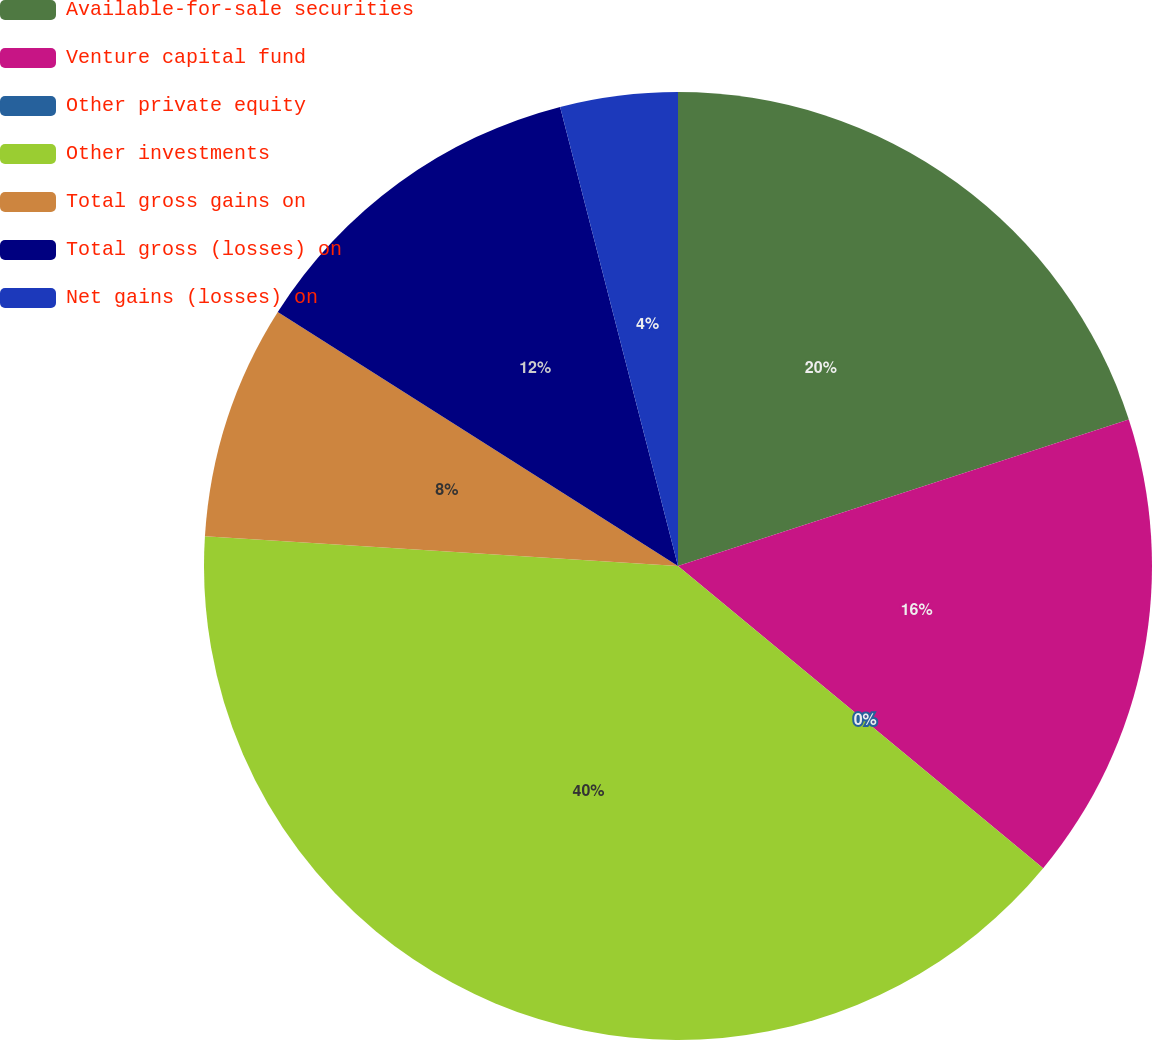Convert chart to OTSL. <chart><loc_0><loc_0><loc_500><loc_500><pie_chart><fcel>Available-for-sale securities<fcel>Venture capital fund<fcel>Other private equity<fcel>Other investments<fcel>Total gross gains on<fcel>Total gross (losses) on<fcel>Net gains (losses) on<nl><fcel>20.0%<fcel>16.0%<fcel>0.0%<fcel>39.99%<fcel>8.0%<fcel>12.0%<fcel>4.0%<nl></chart> 